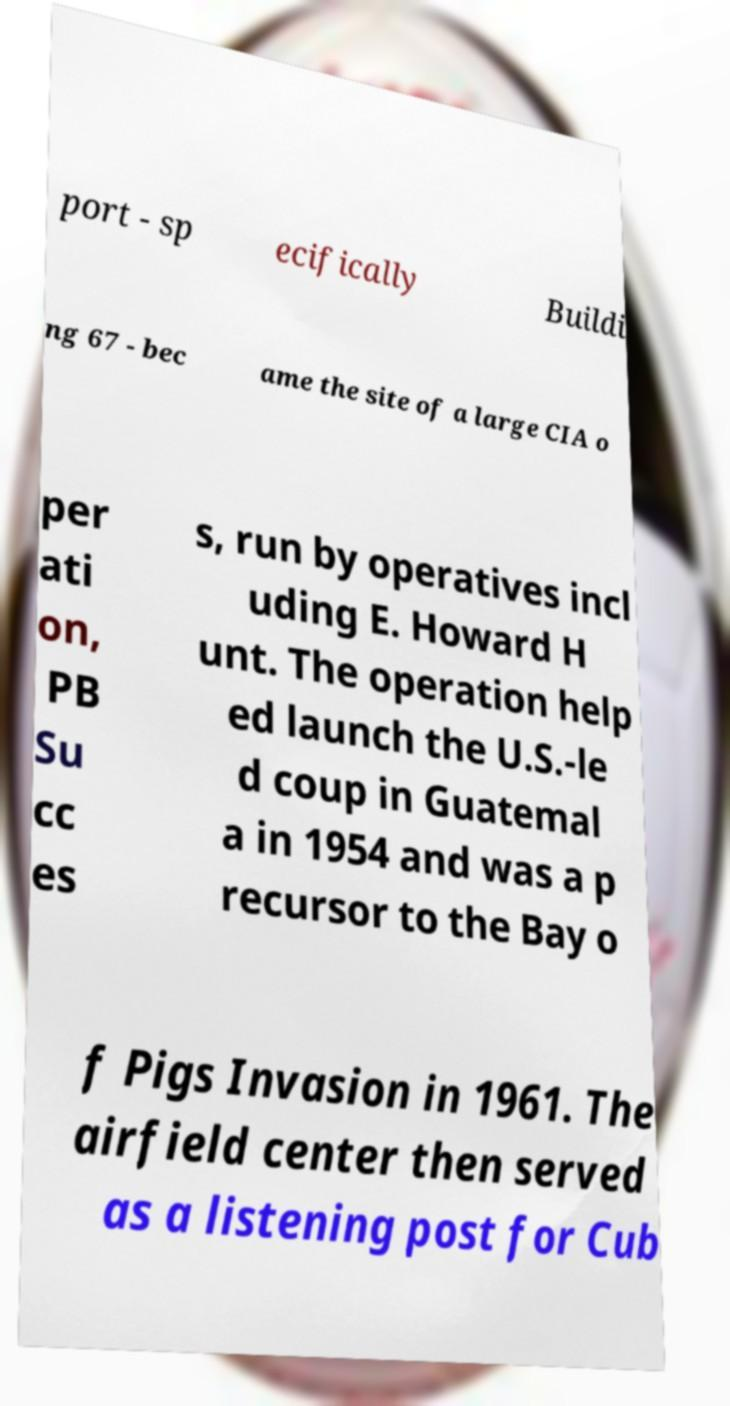There's text embedded in this image that I need extracted. Can you transcribe it verbatim? port - sp ecifically Buildi ng 67 - bec ame the site of a large CIA o per ati on, PB Su cc es s, run by operatives incl uding E. Howard H unt. The operation help ed launch the U.S.-le d coup in Guatemal a in 1954 and was a p recursor to the Bay o f Pigs Invasion in 1961. The airfield center then served as a listening post for Cub 